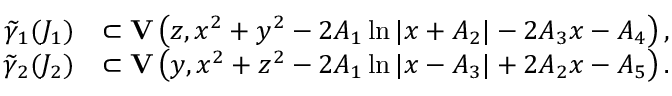<formula> <loc_0><loc_0><loc_500><loc_500>\begin{array} { r l } { \widetilde { \gamma } _ { 1 } ( J _ { 1 } ) } & { \subset { V } \left ( z , x ^ { 2 } + y ^ { 2 } - 2 A _ { 1 } \ln | x + A _ { 2 } | - 2 A _ { 3 } x - A _ { 4 } \right ) , } \\ { \widetilde { \gamma } _ { 2 } ( J _ { 2 } ) } & { \subset { V } \left ( y , x ^ { 2 } + z ^ { 2 } - 2 A _ { 1 } \ln | x - A _ { 3 } | + 2 A _ { 2 } x - A _ { 5 } \right ) . } \end{array}</formula> 